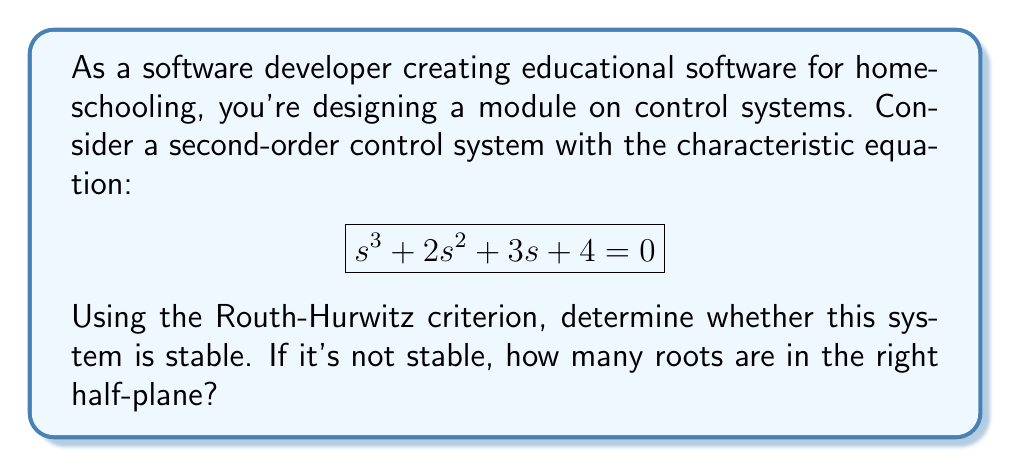Help me with this question. To analyze the stability of this system using the Routh-Hurwitz criterion, we'll follow these steps:

1) First, we arrange the coefficients of the characteristic equation in a Routh array:

   $$ \begin{array}{c|ccc}
   s^3 & 1 & 3 \\
   s^2 & 2 & 4 \\
   s^1 & b_1 & 0 \\
   s^0 & b_2 & 
   \end{array} $$

2) We need to calculate $b_1$ and $b_2$:

   $b_1 = \frac{(2)(3) - (1)(4)}{2} = \frac{6 - 4}{2} = 1$

   $b_2 = \frac{(1)(4) - (2)(0)}{1} = 4$

3) Now our complete Routh array looks like this:

   $$ \begin{array}{c|ccc}
   s^3 & 1 & 3 \\
   s^2 & 2 & 4 \\
   s^1 & 1 & 0 \\
   s^0 & 4 & 
   \end{array} $$

4) According to the Routh-Hurwitz criterion, the number of sign changes in the first column of the Routh array equals the number of roots in the right half-plane.

5) In this case, we see no sign changes in the first column (all coefficients are positive).

6) Therefore, there are no roots in the right half-plane, which means the system is stable.

This analysis shows that the system is stable without needing to solve for the actual roots of the characteristic equation, demonstrating the power and efficiency of the Routh-Hurwitz criterion.
Answer: The system is stable. There are 0 roots in the right half-plane. 